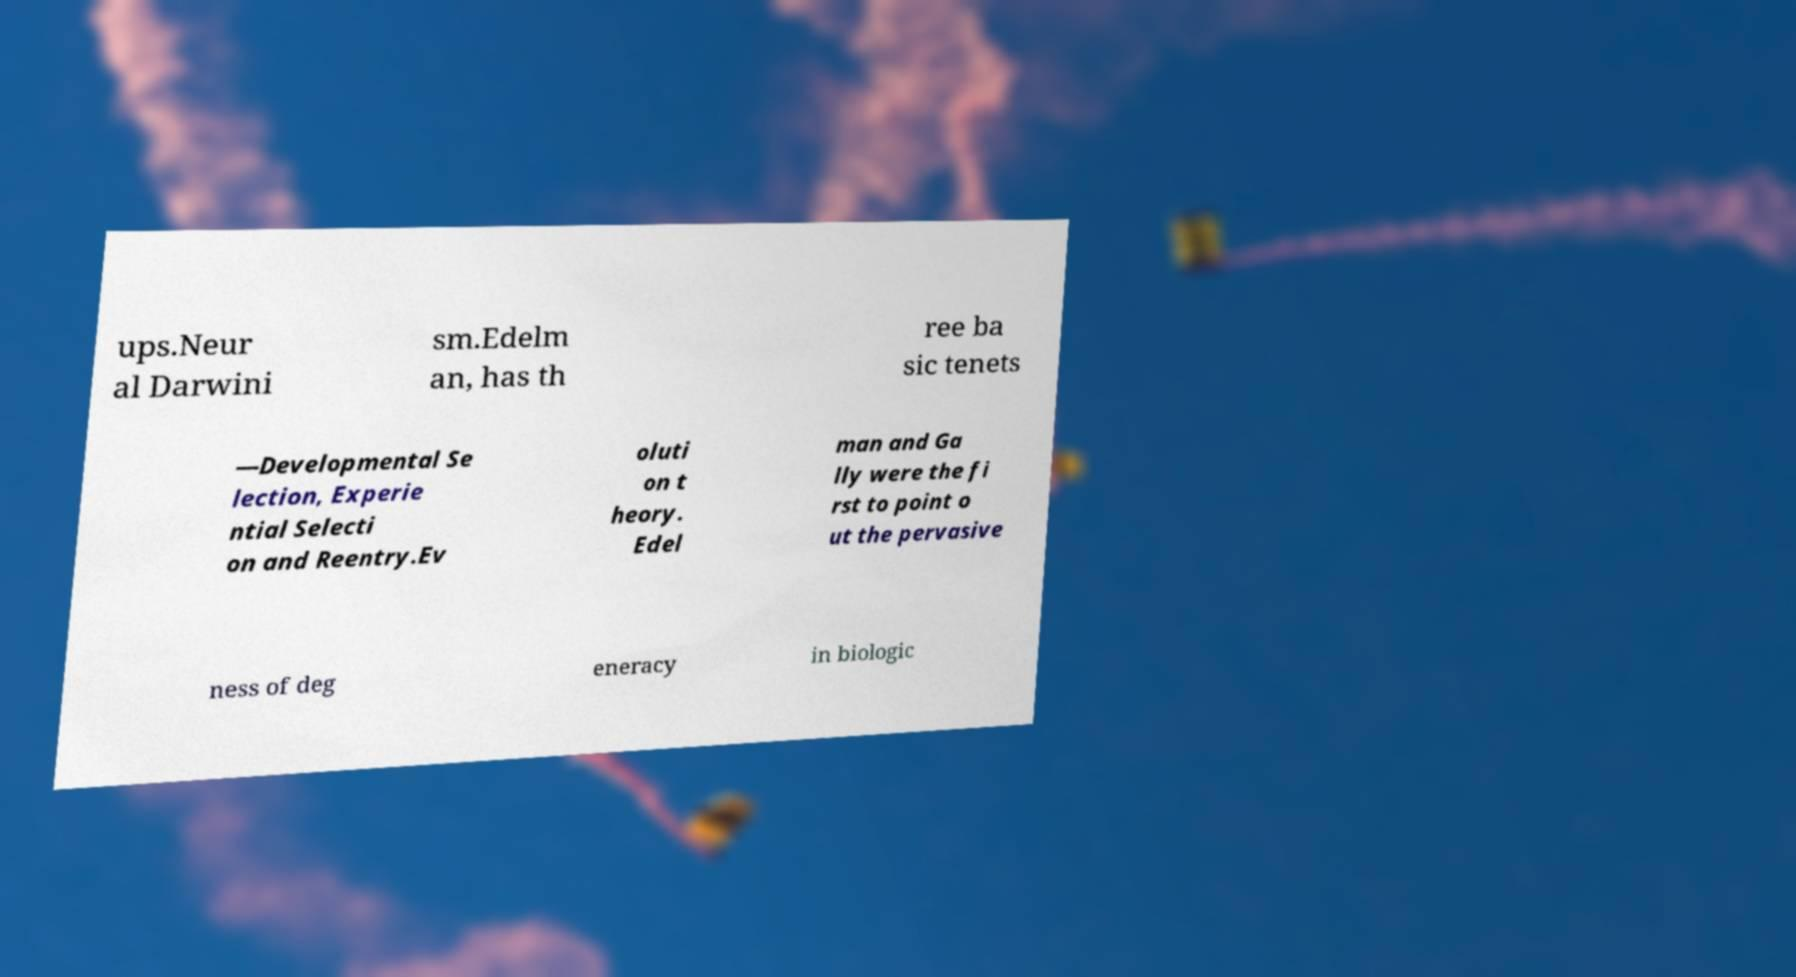What messages or text are displayed in this image? I need them in a readable, typed format. ups.Neur al Darwini sm.Edelm an, has th ree ba sic tenets —Developmental Se lection, Experie ntial Selecti on and Reentry.Ev oluti on t heory. Edel man and Ga lly were the fi rst to point o ut the pervasive ness of deg eneracy in biologic 